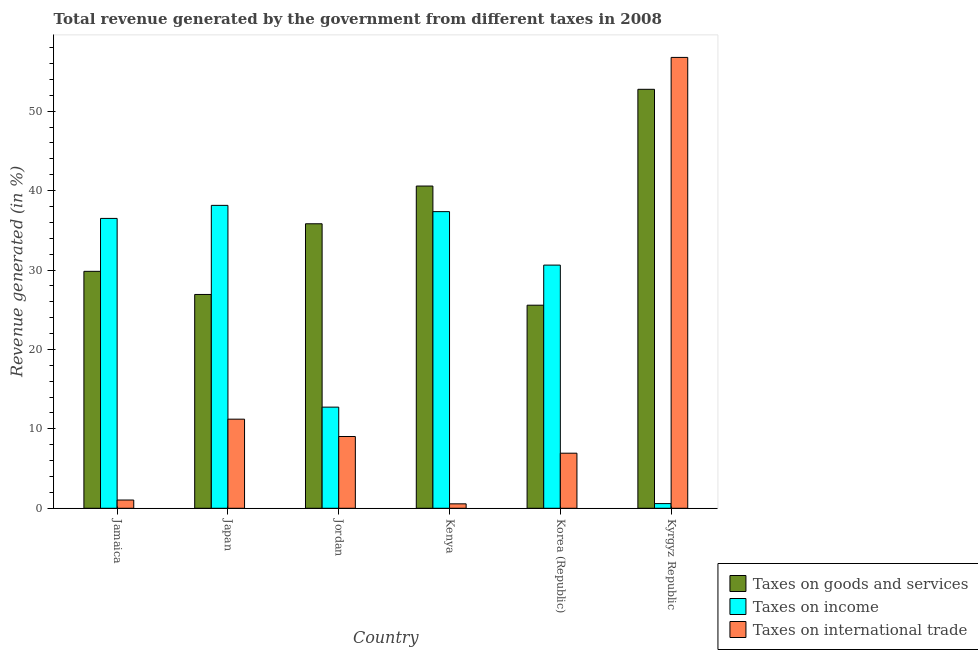Are the number of bars on each tick of the X-axis equal?
Keep it short and to the point. Yes. How many bars are there on the 4th tick from the left?
Keep it short and to the point. 3. How many bars are there on the 4th tick from the right?
Provide a succinct answer. 3. What is the percentage of revenue generated by tax on international trade in Japan?
Keep it short and to the point. 11.22. Across all countries, what is the maximum percentage of revenue generated by tax on international trade?
Ensure brevity in your answer.  56.77. Across all countries, what is the minimum percentage of revenue generated by taxes on goods and services?
Provide a short and direct response. 25.57. In which country was the percentage of revenue generated by tax on international trade maximum?
Your response must be concise. Kyrgyz Republic. In which country was the percentage of revenue generated by taxes on income minimum?
Your answer should be compact. Kyrgyz Republic. What is the total percentage of revenue generated by taxes on goods and services in the graph?
Provide a succinct answer. 211.48. What is the difference between the percentage of revenue generated by taxes on income in Jordan and that in Korea (Republic)?
Provide a short and direct response. -17.88. What is the difference between the percentage of revenue generated by tax on international trade in Japan and the percentage of revenue generated by taxes on income in Kyrgyz Republic?
Offer a terse response. 10.63. What is the average percentage of revenue generated by taxes on income per country?
Ensure brevity in your answer.  25.99. What is the difference between the percentage of revenue generated by taxes on goods and services and percentage of revenue generated by taxes on income in Korea (Republic)?
Offer a very short reply. -5.05. In how many countries, is the percentage of revenue generated by taxes on goods and services greater than 4 %?
Your answer should be very brief. 6. What is the ratio of the percentage of revenue generated by taxes on goods and services in Japan to that in Kenya?
Ensure brevity in your answer.  0.66. Is the percentage of revenue generated by taxes on goods and services in Japan less than that in Jordan?
Provide a succinct answer. Yes. Is the difference between the percentage of revenue generated by tax on international trade in Kenya and Kyrgyz Republic greater than the difference between the percentage of revenue generated by taxes on income in Kenya and Kyrgyz Republic?
Provide a succinct answer. No. What is the difference between the highest and the second highest percentage of revenue generated by tax on international trade?
Offer a terse response. 45.55. What is the difference between the highest and the lowest percentage of revenue generated by taxes on income?
Offer a very short reply. 37.55. In how many countries, is the percentage of revenue generated by taxes on goods and services greater than the average percentage of revenue generated by taxes on goods and services taken over all countries?
Give a very brief answer. 3. Is the sum of the percentage of revenue generated by taxes on goods and services in Jamaica and Kenya greater than the maximum percentage of revenue generated by tax on international trade across all countries?
Ensure brevity in your answer.  Yes. What does the 1st bar from the left in Jordan represents?
Make the answer very short. Taxes on goods and services. What does the 2nd bar from the right in Jordan represents?
Make the answer very short. Taxes on income. Is it the case that in every country, the sum of the percentage of revenue generated by taxes on goods and services and percentage of revenue generated by taxes on income is greater than the percentage of revenue generated by tax on international trade?
Your answer should be very brief. No. Does the graph contain any zero values?
Your answer should be compact. No. Where does the legend appear in the graph?
Offer a terse response. Bottom right. How many legend labels are there?
Provide a short and direct response. 3. How are the legend labels stacked?
Your answer should be very brief. Vertical. What is the title of the graph?
Keep it short and to the point. Total revenue generated by the government from different taxes in 2008. What is the label or title of the Y-axis?
Your answer should be very brief. Revenue generated (in %). What is the Revenue generated (in %) in Taxes on goods and services in Jamaica?
Your response must be concise. 29.83. What is the Revenue generated (in %) of Taxes on income in Jamaica?
Offer a very short reply. 36.5. What is the Revenue generated (in %) of Taxes on international trade in Jamaica?
Ensure brevity in your answer.  1.04. What is the Revenue generated (in %) in Taxes on goods and services in Japan?
Your response must be concise. 26.92. What is the Revenue generated (in %) of Taxes on income in Japan?
Make the answer very short. 38.14. What is the Revenue generated (in %) of Taxes on international trade in Japan?
Offer a very short reply. 11.22. What is the Revenue generated (in %) of Taxes on goods and services in Jordan?
Keep it short and to the point. 35.82. What is the Revenue generated (in %) in Taxes on income in Jordan?
Your answer should be compact. 12.73. What is the Revenue generated (in %) in Taxes on international trade in Jordan?
Keep it short and to the point. 9.04. What is the Revenue generated (in %) of Taxes on goods and services in Kenya?
Give a very brief answer. 40.57. What is the Revenue generated (in %) in Taxes on income in Kenya?
Offer a very short reply. 37.35. What is the Revenue generated (in %) in Taxes on international trade in Kenya?
Your answer should be compact. 0.56. What is the Revenue generated (in %) in Taxes on goods and services in Korea (Republic)?
Offer a very short reply. 25.57. What is the Revenue generated (in %) in Taxes on income in Korea (Republic)?
Make the answer very short. 30.62. What is the Revenue generated (in %) in Taxes on international trade in Korea (Republic)?
Offer a terse response. 6.93. What is the Revenue generated (in %) in Taxes on goods and services in Kyrgyz Republic?
Provide a succinct answer. 52.75. What is the Revenue generated (in %) in Taxes on income in Kyrgyz Republic?
Offer a very short reply. 0.59. What is the Revenue generated (in %) of Taxes on international trade in Kyrgyz Republic?
Offer a terse response. 56.77. Across all countries, what is the maximum Revenue generated (in %) in Taxes on goods and services?
Keep it short and to the point. 52.75. Across all countries, what is the maximum Revenue generated (in %) of Taxes on income?
Provide a short and direct response. 38.14. Across all countries, what is the maximum Revenue generated (in %) in Taxes on international trade?
Offer a terse response. 56.77. Across all countries, what is the minimum Revenue generated (in %) of Taxes on goods and services?
Your answer should be compact. 25.57. Across all countries, what is the minimum Revenue generated (in %) of Taxes on income?
Offer a terse response. 0.59. Across all countries, what is the minimum Revenue generated (in %) of Taxes on international trade?
Provide a succinct answer. 0.56. What is the total Revenue generated (in %) in Taxes on goods and services in the graph?
Provide a short and direct response. 211.48. What is the total Revenue generated (in %) in Taxes on income in the graph?
Your response must be concise. 155.93. What is the total Revenue generated (in %) in Taxes on international trade in the graph?
Your response must be concise. 85.56. What is the difference between the Revenue generated (in %) of Taxes on goods and services in Jamaica and that in Japan?
Make the answer very short. 2.91. What is the difference between the Revenue generated (in %) of Taxes on income in Jamaica and that in Japan?
Offer a terse response. -1.64. What is the difference between the Revenue generated (in %) in Taxes on international trade in Jamaica and that in Japan?
Offer a very short reply. -10.18. What is the difference between the Revenue generated (in %) in Taxes on goods and services in Jamaica and that in Jordan?
Offer a very short reply. -5.99. What is the difference between the Revenue generated (in %) in Taxes on income in Jamaica and that in Jordan?
Your answer should be very brief. 23.76. What is the difference between the Revenue generated (in %) of Taxes on international trade in Jamaica and that in Jordan?
Provide a short and direct response. -8. What is the difference between the Revenue generated (in %) of Taxes on goods and services in Jamaica and that in Kenya?
Make the answer very short. -10.74. What is the difference between the Revenue generated (in %) in Taxes on income in Jamaica and that in Kenya?
Ensure brevity in your answer.  -0.85. What is the difference between the Revenue generated (in %) of Taxes on international trade in Jamaica and that in Kenya?
Offer a terse response. 0.48. What is the difference between the Revenue generated (in %) in Taxes on goods and services in Jamaica and that in Korea (Republic)?
Provide a short and direct response. 4.26. What is the difference between the Revenue generated (in %) in Taxes on income in Jamaica and that in Korea (Republic)?
Your response must be concise. 5.88. What is the difference between the Revenue generated (in %) in Taxes on international trade in Jamaica and that in Korea (Republic)?
Provide a succinct answer. -5.9. What is the difference between the Revenue generated (in %) in Taxes on goods and services in Jamaica and that in Kyrgyz Republic?
Provide a succinct answer. -22.92. What is the difference between the Revenue generated (in %) in Taxes on income in Jamaica and that in Kyrgyz Republic?
Ensure brevity in your answer.  35.91. What is the difference between the Revenue generated (in %) in Taxes on international trade in Jamaica and that in Kyrgyz Republic?
Make the answer very short. -55.73. What is the difference between the Revenue generated (in %) of Taxes on goods and services in Japan and that in Jordan?
Keep it short and to the point. -8.9. What is the difference between the Revenue generated (in %) of Taxes on income in Japan and that in Jordan?
Your answer should be compact. 25.41. What is the difference between the Revenue generated (in %) of Taxes on international trade in Japan and that in Jordan?
Your answer should be compact. 2.19. What is the difference between the Revenue generated (in %) in Taxes on goods and services in Japan and that in Kenya?
Ensure brevity in your answer.  -13.65. What is the difference between the Revenue generated (in %) in Taxes on income in Japan and that in Kenya?
Provide a short and direct response. 0.79. What is the difference between the Revenue generated (in %) of Taxes on international trade in Japan and that in Kenya?
Your response must be concise. 10.66. What is the difference between the Revenue generated (in %) of Taxes on goods and services in Japan and that in Korea (Republic)?
Your answer should be compact. 1.35. What is the difference between the Revenue generated (in %) in Taxes on income in Japan and that in Korea (Republic)?
Provide a succinct answer. 7.52. What is the difference between the Revenue generated (in %) of Taxes on international trade in Japan and that in Korea (Republic)?
Make the answer very short. 4.29. What is the difference between the Revenue generated (in %) in Taxes on goods and services in Japan and that in Kyrgyz Republic?
Offer a terse response. -25.83. What is the difference between the Revenue generated (in %) in Taxes on income in Japan and that in Kyrgyz Republic?
Make the answer very short. 37.55. What is the difference between the Revenue generated (in %) in Taxes on international trade in Japan and that in Kyrgyz Republic?
Offer a terse response. -45.55. What is the difference between the Revenue generated (in %) of Taxes on goods and services in Jordan and that in Kenya?
Provide a succinct answer. -4.75. What is the difference between the Revenue generated (in %) in Taxes on income in Jordan and that in Kenya?
Offer a terse response. -24.62. What is the difference between the Revenue generated (in %) of Taxes on international trade in Jordan and that in Kenya?
Offer a terse response. 8.48. What is the difference between the Revenue generated (in %) in Taxes on goods and services in Jordan and that in Korea (Republic)?
Offer a terse response. 10.25. What is the difference between the Revenue generated (in %) of Taxes on income in Jordan and that in Korea (Republic)?
Provide a succinct answer. -17.89. What is the difference between the Revenue generated (in %) of Taxes on international trade in Jordan and that in Korea (Republic)?
Give a very brief answer. 2.1. What is the difference between the Revenue generated (in %) in Taxes on goods and services in Jordan and that in Kyrgyz Republic?
Keep it short and to the point. -16.93. What is the difference between the Revenue generated (in %) in Taxes on income in Jordan and that in Kyrgyz Republic?
Offer a very short reply. 12.15. What is the difference between the Revenue generated (in %) of Taxes on international trade in Jordan and that in Kyrgyz Republic?
Offer a terse response. -47.73. What is the difference between the Revenue generated (in %) of Taxes on goods and services in Kenya and that in Korea (Republic)?
Make the answer very short. 15. What is the difference between the Revenue generated (in %) in Taxes on income in Kenya and that in Korea (Republic)?
Provide a short and direct response. 6.73. What is the difference between the Revenue generated (in %) of Taxes on international trade in Kenya and that in Korea (Republic)?
Provide a succinct answer. -6.38. What is the difference between the Revenue generated (in %) of Taxes on goods and services in Kenya and that in Kyrgyz Republic?
Offer a terse response. -12.18. What is the difference between the Revenue generated (in %) of Taxes on income in Kenya and that in Kyrgyz Republic?
Give a very brief answer. 36.76. What is the difference between the Revenue generated (in %) of Taxes on international trade in Kenya and that in Kyrgyz Republic?
Provide a succinct answer. -56.21. What is the difference between the Revenue generated (in %) of Taxes on goods and services in Korea (Republic) and that in Kyrgyz Republic?
Give a very brief answer. -27.18. What is the difference between the Revenue generated (in %) in Taxes on income in Korea (Republic) and that in Kyrgyz Republic?
Your answer should be very brief. 30.03. What is the difference between the Revenue generated (in %) of Taxes on international trade in Korea (Republic) and that in Kyrgyz Republic?
Offer a terse response. -49.83. What is the difference between the Revenue generated (in %) of Taxes on goods and services in Jamaica and the Revenue generated (in %) of Taxes on income in Japan?
Offer a very short reply. -8.31. What is the difference between the Revenue generated (in %) in Taxes on goods and services in Jamaica and the Revenue generated (in %) in Taxes on international trade in Japan?
Give a very brief answer. 18.61. What is the difference between the Revenue generated (in %) in Taxes on income in Jamaica and the Revenue generated (in %) in Taxes on international trade in Japan?
Your response must be concise. 25.28. What is the difference between the Revenue generated (in %) in Taxes on goods and services in Jamaica and the Revenue generated (in %) in Taxes on income in Jordan?
Provide a short and direct response. 17.1. What is the difference between the Revenue generated (in %) of Taxes on goods and services in Jamaica and the Revenue generated (in %) of Taxes on international trade in Jordan?
Make the answer very short. 20.8. What is the difference between the Revenue generated (in %) of Taxes on income in Jamaica and the Revenue generated (in %) of Taxes on international trade in Jordan?
Your response must be concise. 27.46. What is the difference between the Revenue generated (in %) of Taxes on goods and services in Jamaica and the Revenue generated (in %) of Taxes on income in Kenya?
Ensure brevity in your answer.  -7.52. What is the difference between the Revenue generated (in %) of Taxes on goods and services in Jamaica and the Revenue generated (in %) of Taxes on international trade in Kenya?
Give a very brief answer. 29.27. What is the difference between the Revenue generated (in %) in Taxes on income in Jamaica and the Revenue generated (in %) in Taxes on international trade in Kenya?
Offer a very short reply. 35.94. What is the difference between the Revenue generated (in %) in Taxes on goods and services in Jamaica and the Revenue generated (in %) in Taxes on income in Korea (Republic)?
Provide a succinct answer. -0.79. What is the difference between the Revenue generated (in %) of Taxes on goods and services in Jamaica and the Revenue generated (in %) of Taxes on international trade in Korea (Republic)?
Offer a very short reply. 22.9. What is the difference between the Revenue generated (in %) in Taxes on income in Jamaica and the Revenue generated (in %) in Taxes on international trade in Korea (Republic)?
Provide a short and direct response. 29.56. What is the difference between the Revenue generated (in %) in Taxes on goods and services in Jamaica and the Revenue generated (in %) in Taxes on income in Kyrgyz Republic?
Provide a short and direct response. 29.24. What is the difference between the Revenue generated (in %) of Taxes on goods and services in Jamaica and the Revenue generated (in %) of Taxes on international trade in Kyrgyz Republic?
Give a very brief answer. -26.94. What is the difference between the Revenue generated (in %) in Taxes on income in Jamaica and the Revenue generated (in %) in Taxes on international trade in Kyrgyz Republic?
Your response must be concise. -20.27. What is the difference between the Revenue generated (in %) in Taxes on goods and services in Japan and the Revenue generated (in %) in Taxes on income in Jordan?
Provide a short and direct response. 14.19. What is the difference between the Revenue generated (in %) of Taxes on goods and services in Japan and the Revenue generated (in %) of Taxes on international trade in Jordan?
Make the answer very short. 17.89. What is the difference between the Revenue generated (in %) in Taxes on income in Japan and the Revenue generated (in %) in Taxes on international trade in Jordan?
Ensure brevity in your answer.  29.11. What is the difference between the Revenue generated (in %) in Taxes on goods and services in Japan and the Revenue generated (in %) in Taxes on income in Kenya?
Provide a succinct answer. -10.43. What is the difference between the Revenue generated (in %) in Taxes on goods and services in Japan and the Revenue generated (in %) in Taxes on international trade in Kenya?
Offer a terse response. 26.36. What is the difference between the Revenue generated (in %) of Taxes on income in Japan and the Revenue generated (in %) of Taxes on international trade in Kenya?
Provide a short and direct response. 37.58. What is the difference between the Revenue generated (in %) of Taxes on goods and services in Japan and the Revenue generated (in %) of Taxes on income in Korea (Republic)?
Your response must be concise. -3.7. What is the difference between the Revenue generated (in %) of Taxes on goods and services in Japan and the Revenue generated (in %) of Taxes on international trade in Korea (Republic)?
Ensure brevity in your answer.  19.99. What is the difference between the Revenue generated (in %) of Taxes on income in Japan and the Revenue generated (in %) of Taxes on international trade in Korea (Republic)?
Your answer should be very brief. 31.21. What is the difference between the Revenue generated (in %) in Taxes on goods and services in Japan and the Revenue generated (in %) in Taxes on income in Kyrgyz Republic?
Your answer should be very brief. 26.33. What is the difference between the Revenue generated (in %) in Taxes on goods and services in Japan and the Revenue generated (in %) in Taxes on international trade in Kyrgyz Republic?
Your answer should be very brief. -29.85. What is the difference between the Revenue generated (in %) of Taxes on income in Japan and the Revenue generated (in %) of Taxes on international trade in Kyrgyz Republic?
Your answer should be very brief. -18.63. What is the difference between the Revenue generated (in %) of Taxes on goods and services in Jordan and the Revenue generated (in %) of Taxes on income in Kenya?
Your answer should be very brief. -1.53. What is the difference between the Revenue generated (in %) in Taxes on goods and services in Jordan and the Revenue generated (in %) in Taxes on international trade in Kenya?
Your response must be concise. 35.26. What is the difference between the Revenue generated (in %) of Taxes on income in Jordan and the Revenue generated (in %) of Taxes on international trade in Kenya?
Provide a short and direct response. 12.18. What is the difference between the Revenue generated (in %) in Taxes on goods and services in Jordan and the Revenue generated (in %) in Taxes on income in Korea (Republic)?
Make the answer very short. 5.2. What is the difference between the Revenue generated (in %) of Taxes on goods and services in Jordan and the Revenue generated (in %) of Taxes on international trade in Korea (Republic)?
Provide a succinct answer. 28.89. What is the difference between the Revenue generated (in %) of Taxes on income in Jordan and the Revenue generated (in %) of Taxes on international trade in Korea (Republic)?
Keep it short and to the point. 5.8. What is the difference between the Revenue generated (in %) in Taxes on goods and services in Jordan and the Revenue generated (in %) in Taxes on income in Kyrgyz Republic?
Your answer should be compact. 35.23. What is the difference between the Revenue generated (in %) in Taxes on goods and services in Jordan and the Revenue generated (in %) in Taxes on international trade in Kyrgyz Republic?
Your response must be concise. -20.95. What is the difference between the Revenue generated (in %) in Taxes on income in Jordan and the Revenue generated (in %) in Taxes on international trade in Kyrgyz Republic?
Your response must be concise. -44.03. What is the difference between the Revenue generated (in %) in Taxes on goods and services in Kenya and the Revenue generated (in %) in Taxes on income in Korea (Republic)?
Offer a terse response. 9.96. What is the difference between the Revenue generated (in %) in Taxes on goods and services in Kenya and the Revenue generated (in %) in Taxes on international trade in Korea (Republic)?
Offer a terse response. 33.64. What is the difference between the Revenue generated (in %) of Taxes on income in Kenya and the Revenue generated (in %) of Taxes on international trade in Korea (Republic)?
Give a very brief answer. 30.42. What is the difference between the Revenue generated (in %) in Taxes on goods and services in Kenya and the Revenue generated (in %) in Taxes on income in Kyrgyz Republic?
Provide a succinct answer. 39.99. What is the difference between the Revenue generated (in %) in Taxes on goods and services in Kenya and the Revenue generated (in %) in Taxes on international trade in Kyrgyz Republic?
Your answer should be very brief. -16.19. What is the difference between the Revenue generated (in %) of Taxes on income in Kenya and the Revenue generated (in %) of Taxes on international trade in Kyrgyz Republic?
Your response must be concise. -19.42. What is the difference between the Revenue generated (in %) in Taxes on goods and services in Korea (Republic) and the Revenue generated (in %) in Taxes on income in Kyrgyz Republic?
Provide a succinct answer. 24.98. What is the difference between the Revenue generated (in %) of Taxes on goods and services in Korea (Republic) and the Revenue generated (in %) of Taxes on international trade in Kyrgyz Republic?
Keep it short and to the point. -31.2. What is the difference between the Revenue generated (in %) in Taxes on income in Korea (Republic) and the Revenue generated (in %) in Taxes on international trade in Kyrgyz Republic?
Keep it short and to the point. -26.15. What is the average Revenue generated (in %) in Taxes on goods and services per country?
Your answer should be compact. 35.25. What is the average Revenue generated (in %) of Taxes on income per country?
Provide a short and direct response. 25.99. What is the average Revenue generated (in %) in Taxes on international trade per country?
Your response must be concise. 14.26. What is the difference between the Revenue generated (in %) of Taxes on goods and services and Revenue generated (in %) of Taxes on income in Jamaica?
Your answer should be very brief. -6.66. What is the difference between the Revenue generated (in %) in Taxes on goods and services and Revenue generated (in %) in Taxes on international trade in Jamaica?
Offer a terse response. 28.8. What is the difference between the Revenue generated (in %) in Taxes on income and Revenue generated (in %) in Taxes on international trade in Jamaica?
Your answer should be very brief. 35.46. What is the difference between the Revenue generated (in %) in Taxes on goods and services and Revenue generated (in %) in Taxes on income in Japan?
Keep it short and to the point. -11.22. What is the difference between the Revenue generated (in %) in Taxes on goods and services and Revenue generated (in %) in Taxes on international trade in Japan?
Make the answer very short. 15.7. What is the difference between the Revenue generated (in %) in Taxes on income and Revenue generated (in %) in Taxes on international trade in Japan?
Provide a short and direct response. 26.92. What is the difference between the Revenue generated (in %) of Taxes on goods and services and Revenue generated (in %) of Taxes on income in Jordan?
Your answer should be very brief. 23.09. What is the difference between the Revenue generated (in %) in Taxes on goods and services and Revenue generated (in %) in Taxes on international trade in Jordan?
Your answer should be compact. 26.79. What is the difference between the Revenue generated (in %) in Taxes on income and Revenue generated (in %) in Taxes on international trade in Jordan?
Give a very brief answer. 3.7. What is the difference between the Revenue generated (in %) in Taxes on goods and services and Revenue generated (in %) in Taxes on income in Kenya?
Offer a terse response. 3.22. What is the difference between the Revenue generated (in %) of Taxes on goods and services and Revenue generated (in %) of Taxes on international trade in Kenya?
Make the answer very short. 40.02. What is the difference between the Revenue generated (in %) of Taxes on income and Revenue generated (in %) of Taxes on international trade in Kenya?
Your answer should be compact. 36.79. What is the difference between the Revenue generated (in %) of Taxes on goods and services and Revenue generated (in %) of Taxes on income in Korea (Republic)?
Make the answer very short. -5.05. What is the difference between the Revenue generated (in %) in Taxes on goods and services and Revenue generated (in %) in Taxes on international trade in Korea (Republic)?
Offer a terse response. 18.64. What is the difference between the Revenue generated (in %) of Taxes on income and Revenue generated (in %) of Taxes on international trade in Korea (Republic)?
Make the answer very short. 23.68. What is the difference between the Revenue generated (in %) of Taxes on goods and services and Revenue generated (in %) of Taxes on income in Kyrgyz Republic?
Offer a very short reply. 52.17. What is the difference between the Revenue generated (in %) in Taxes on goods and services and Revenue generated (in %) in Taxes on international trade in Kyrgyz Republic?
Provide a short and direct response. -4.01. What is the difference between the Revenue generated (in %) of Taxes on income and Revenue generated (in %) of Taxes on international trade in Kyrgyz Republic?
Your answer should be very brief. -56.18. What is the ratio of the Revenue generated (in %) of Taxes on goods and services in Jamaica to that in Japan?
Offer a very short reply. 1.11. What is the ratio of the Revenue generated (in %) of Taxes on income in Jamaica to that in Japan?
Provide a succinct answer. 0.96. What is the ratio of the Revenue generated (in %) of Taxes on international trade in Jamaica to that in Japan?
Your answer should be compact. 0.09. What is the ratio of the Revenue generated (in %) in Taxes on goods and services in Jamaica to that in Jordan?
Give a very brief answer. 0.83. What is the ratio of the Revenue generated (in %) in Taxes on income in Jamaica to that in Jordan?
Provide a short and direct response. 2.87. What is the ratio of the Revenue generated (in %) in Taxes on international trade in Jamaica to that in Jordan?
Ensure brevity in your answer.  0.11. What is the ratio of the Revenue generated (in %) in Taxes on goods and services in Jamaica to that in Kenya?
Your answer should be very brief. 0.74. What is the ratio of the Revenue generated (in %) of Taxes on income in Jamaica to that in Kenya?
Your answer should be very brief. 0.98. What is the ratio of the Revenue generated (in %) of Taxes on international trade in Jamaica to that in Kenya?
Your answer should be very brief. 1.86. What is the ratio of the Revenue generated (in %) of Taxes on goods and services in Jamaica to that in Korea (Republic)?
Your answer should be very brief. 1.17. What is the ratio of the Revenue generated (in %) in Taxes on income in Jamaica to that in Korea (Republic)?
Ensure brevity in your answer.  1.19. What is the ratio of the Revenue generated (in %) in Taxes on international trade in Jamaica to that in Korea (Republic)?
Keep it short and to the point. 0.15. What is the ratio of the Revenue generated (in %) of Taxes on goods and services in Jamaica to that in Kyrgyz Republic?
Offer a terse response. 0.57. What is the ratio of the Revenue generated (in %) of Taxes on international trade in Jamaica to that in Kyrgyz Republic?
Keep it short and to the point. 0.02. What is the ratio of the Revenue generated (in %) of Taxes on goods and services in Japan to that in Jordan?
Offer a terse response. 0.75. What is the ratio of the Revenue generated (in %) of Taxes on income in Japan to that in Jordan?
Offer a terse response. 3. What is the ratio of the Revenue generated (in %) of Taxes on international trade in Japan to that in Jordan?
Ensure brevity in your answer.  1.24. What is the ratio of the Revenue generated (in %) of Taxes on goods and services in Japan to that in Kenya?
Your response must be concise. 0.66. What is the ratio of the Revenue generated (in %) in Taxes on income in Japan to that in Kenya?
Make the answer very short. 1.02. What is the ratio of the Revenue generated (in %) of Taxes on international trade in Japan to that in Kenya?
Give a very brief answer. 20.08. What is the ratio of the Revenue generated (in %) in Taxes on goods and services in Japan to that in Korea (Republic)?
Your response must be concise. 1.05. What is the ratio of the Revenue generated (in %) of Taxes on income in Japan to that in Korea (Republic)?
Give a very brief answer. 1.25. What is the ratio of the Revenue generated (in %) of Taxes on international trade in Japan to that in Korea (Republic)?
Ensure brevity in your answer.  1.62. What is the ratio of the Revenue generated (in %) of Taxes on goods and services in Japan to that in Kyrgyz Republic?
Your answer should be very brief. 0.51. What is the ratio of the Revenue generated (in %) in Taxes on income in Japan to that in Kyrgyz Republic?
Your answer should be compact. 64.79. What is the ratio of the Revenue generated (in %) of Taxes on international trade in Japan to that in Kyrgyz Republic?
Give a very brief answer. 0.2. What is the ratio of the Revenue generated (in %) in Taxes on goods and services in Jordan to that in Kenya?
Provide a short and direct response. 0.88. What is the ratio of the Revenue generated (in %) in Taxes on income in Jordan to that in Kenya?
Provide a succinct answer. 0.34. What is the ratio of the Revenue generated (in %) of Taxes on international trade in Jordan to that in Kenya?
Your answer should be very brief. 16.17. What is the ratio of the Revenue generated (in %) in Taxes on goods and services in Jordan to that in Korea (Republic)?
Make the answer very short. 1.4. What is the ratio of the Revenue generated (in %) of Taxes on income in Jordan to that in Korea (Republic)?
Your response must be concise. 0.42. What is the ratio of the Revenue generated (in %) of Taxes on international trade in Jordan to that in Korea (Republic)?
Your answer should be compact. 1.3. What is the ratio of the Revenue generated (in %) in Taxes on goods and services in Jordan to that in Kyrgyz Republic?
Make the answer very short. 0.68. What is the ratio of the Revenue generated (in %) in Taxes on income in Jordan to that in Kyrgyz Republic?
Give a very brief answer. 21.63. What is the ratio of the Revenue generated (in %) of Taxes on international trade in Jordan to that in Kyrgyz Republic?
Make the answer very short. 0.16. What is the ratio of the Revenue generated (in %) in Taxes on goods and services in Kenya to that in Korea (Republic)?
Keep it short and to the point. 1.59. What is the ratio of the Revenue generated (in %) in Taxes on income in Kenya to that in Korea (Republic)?
Your answer should be compact. 1.22. What is the ratio of the Revenue generated (in %) in Taxes on international trade in Kenya to that in Korea (Republic)?
Provide a short and direct response. 0.08. What is the ratio of the Revenue generated (in %) of Taxes on goods and services in Kenya to that in Kyrgyz Republic?
Your answer should be very brief. 0.77. What is the ratio of the Revenue generated (in %) of Taxes on income in Kenya to that in Kyrgyz Republic?
Your answer should be compact. 63.45. What is the ratio of the Revenue generated (in %) in Taxes on international trade in Kenya to that in Kyrgyz Republic?
Give a very brief answer. 0.01. What is the ratio of the Revenue generated (in %) of Taxes on goods and services in Korea (Republic) to that in Kyrgyz Republic?
Keep it short and to the point. 0.48. What is the ratio of the Revenue generated (in %) of Taxes on income in Korea (Republic) to that in Kyrgyz Republic?
Provide a short and direct response. 52.02. What is the ratio of the Revenue generated (in %) of Taxes on international trade in Korea (Republic) to that in Kyrgyz Republic?
Provide a succinct answer. 0.12. What is the difference between the highest and the second highest Revenue generated (in %) of Taxes on goods and services?
Ensure brevity in your answer.  12.18. What is the difference between the highest and the second highest Revenue generated (in %) of Taxes on income?
Keep it short and to the point. 0.79. What is the difference between the highest and the second highest Revenue generated (in %) in Taxes on international trade?
Give a very brief answer. 45.55. What is the difference between the highest and the lowest Revenue generated (in %) of Taxes on goods and services?
Make the answer very short. 27.18. What is the difference between the highest and the lowest Revenue generated (in %) of Taxes on income?
Your answer should be very brief. 37.55. What is the difference between the highest and the lowest Revenue generated (in %) of Taxes on international trade?
Keep it short and to the point. 56.21. 